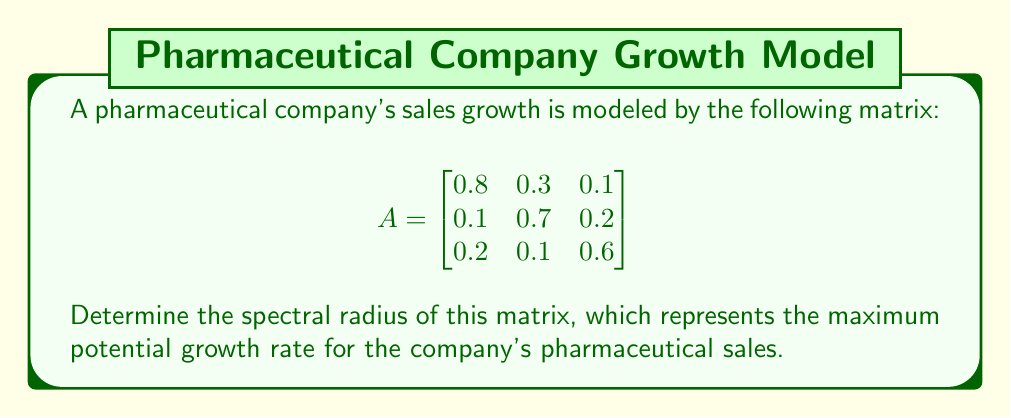Show me your answer to this math problem. To find the spectral radius of matrix A, we need to follow these steps:

1) First, calculate the characteristic polynomial of A:
   $det(A - \lambda I) = 0$
   
   $$\begin{vmatrix}
   0.8-\lambda & 0.3 & 0.1 \\
   0.1 & 0.7-\lambda & 0.2 \\
   0.2 & 0.1 & 0.6-\lambda
   \end{vmatrix} = 0$$

2) Expanding this determinant:
   $(\lambda-0.8)(\lambda-0.7)(\lambda-0.6) - 0.3 \cdot 0.1 \cdot 0.2 - 0.1 \cdot 0.2 \cdot 0.1 = 0$
   
   $\lambda^3 - 2.1\lambda^2 + 1.37\lambda - 0.276 - 0.006 - 0.002 = 0$
   
   $\lambda^3 - 2.1\lambda^2 + 1.37\lambda - 0.284 = 0$

3) The roots of this polynomial are the eigenvalues of A. We can use the cubic formula or numerical methods to find these roots:

   $\lambda_1 \approx 1.0404$
   $\lambda_2 \approx 0.5298$
   $\lambda_3 \approx 0.5298$

4) The spectral radius is the maximum absolute value of these eigenvalues:

   $\rho(A) = \max(|\lambda_1|, |\lambda_2|, |\lambda_3|) = |\lambda_1| \approx 1.0404$

This value being slightly over 1 indicates a slow but steady growth potential for the company's pharmaceutical sales.
Answer: $\rho(A) \approx 1.0404$ 